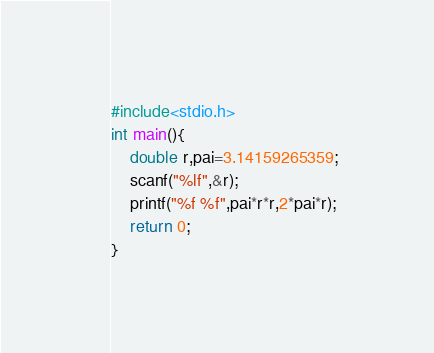Convert code to text. <code><loc_0><loc_0><loc_500><loc_500><_C_>#include<stdio.h>
int main(){
	double r,pai=3.14159265359;
	scanf("%lf",&r);
	printf("%f %f",pai*r*r,2*pai*r);
	return 0;
}</code> 